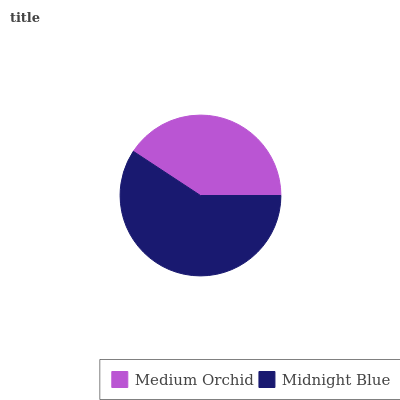Is Medium Orchid the minimum?
Answer yes or no. Yes. Is Midnight Blue the maximum?
Answer yes or no. Yes. Is Midnight Blue the minimum?
Answer yes or no. No. Is Midnight Blue greater than Medium Orchid?
Answer yes or no. Yes. Is Medium Orchid less than Midnight Blue?
Answer yes or no. Yes. Is Medium Orchid greater than Midnight Blue?
Answer yes or no. No. Is Midnight Blue less than Medium Orchid?
Answer yes or no. No. Is Midnight Blue the high median?
Answer yes or no. Yes. Is Medium Orchid the low median?
Answer yes or no. Yes. Is Medium Orchid the high median?
Answer yes or no. No. Is Midnight Blue the low median?
Answer yes or no. No. 